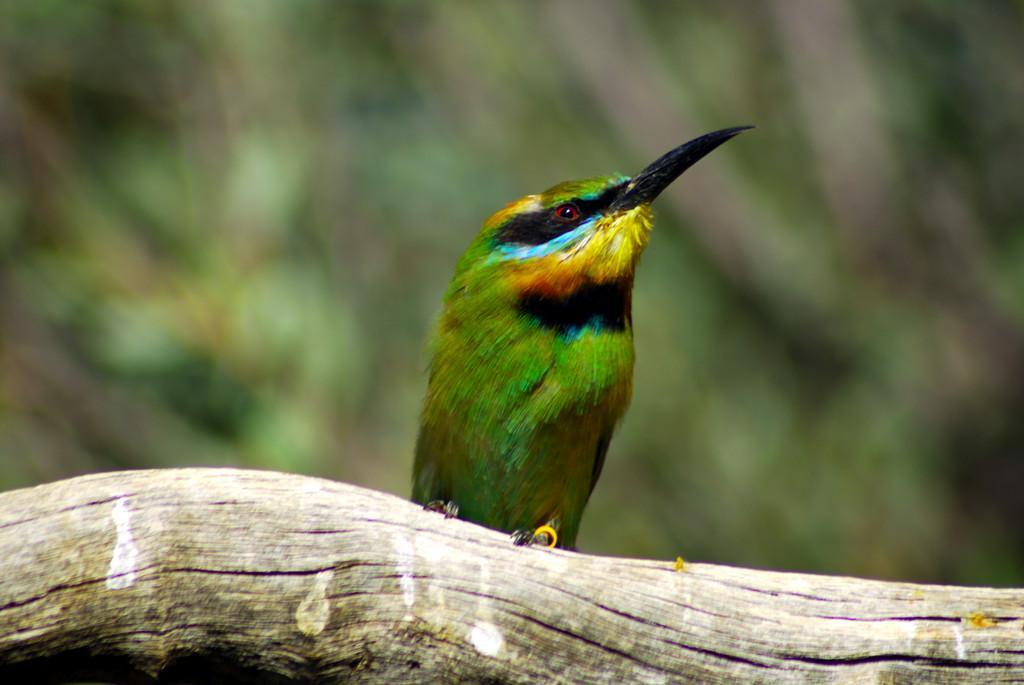How would you summarize this image in a sentence or two? In the image we can see a bird, sitting on the tree log and the background is blurred. 